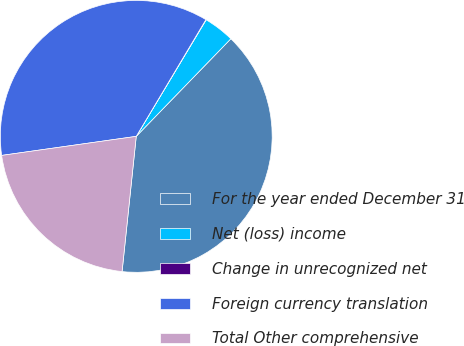Convert chart. <chart><loc_0><loc_0><loc_500><loc_500><pie_chart><fcel>For the year ended December 31<fcel>Net (loss) income<fcel>Change in unrecognized net<fcel>Foreign currency translation<fcel>Total Other comprehensive<nl><fcel>39.41%<fcel>3.65%<fcel>0.04%<fcel>35.8%<fcel>21.1%<nl></chart> 